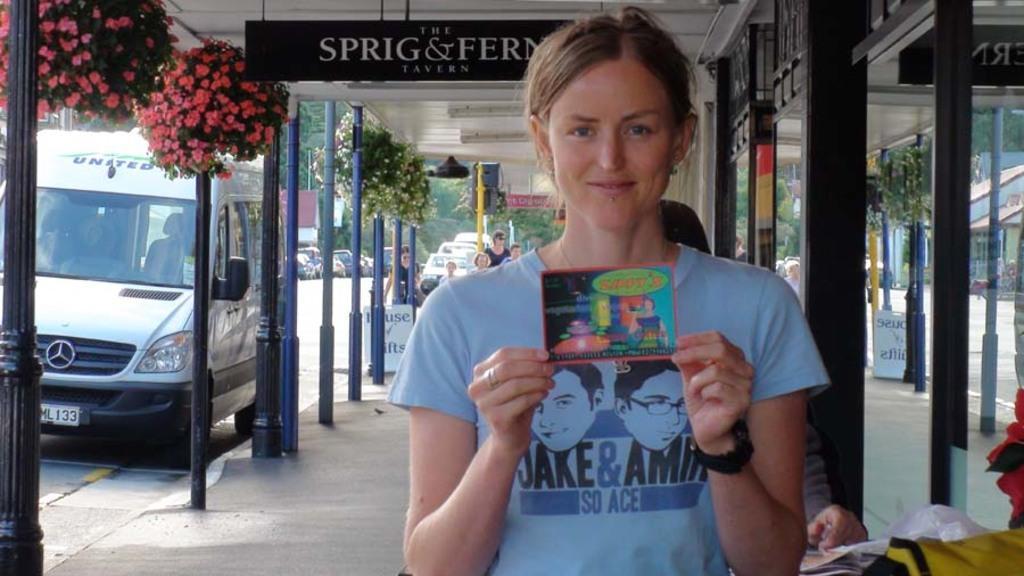Describe this image in one or two sentences. Here in this picture we can see a woman in the front standing and she is holding something in her hand and behind her we can see van, trucks and cars present all over there on the road and we can see other people also standing here and there and we can see flower plants hanging on the roof and we can see poles all over there and in the far we can see trees all over there. 